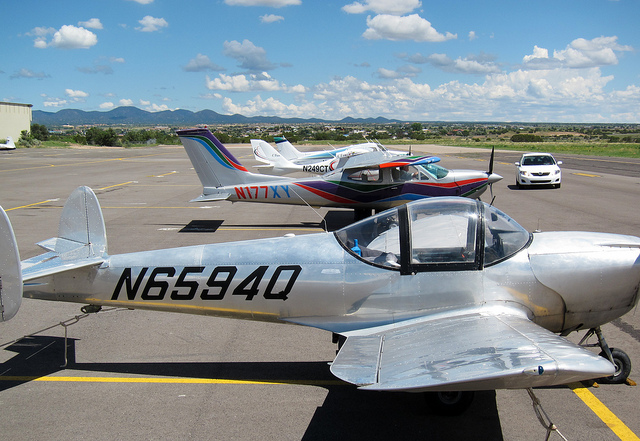What are cables hooked to these planes for? The cables connected to aircraft are often used for grounding and securing the airplane to prevent movement when parked, especially during periods of strong winds. This ensures the safety of the aircraft on the ground. While option B mentions holding steady, which is related to this purpose, the enhanced answer provides more context as to why the planes might be tethered. 